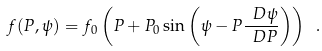<formula> <loc_0><loc_0><loc_500><loc_500>f ( P , \psi ) = f _ { 0 } \left ( P + P _ { 0 } \sin \left ( \psi - P \frac { \ D \psi } { \ D P } \right ) \right ) \ .</formula> 